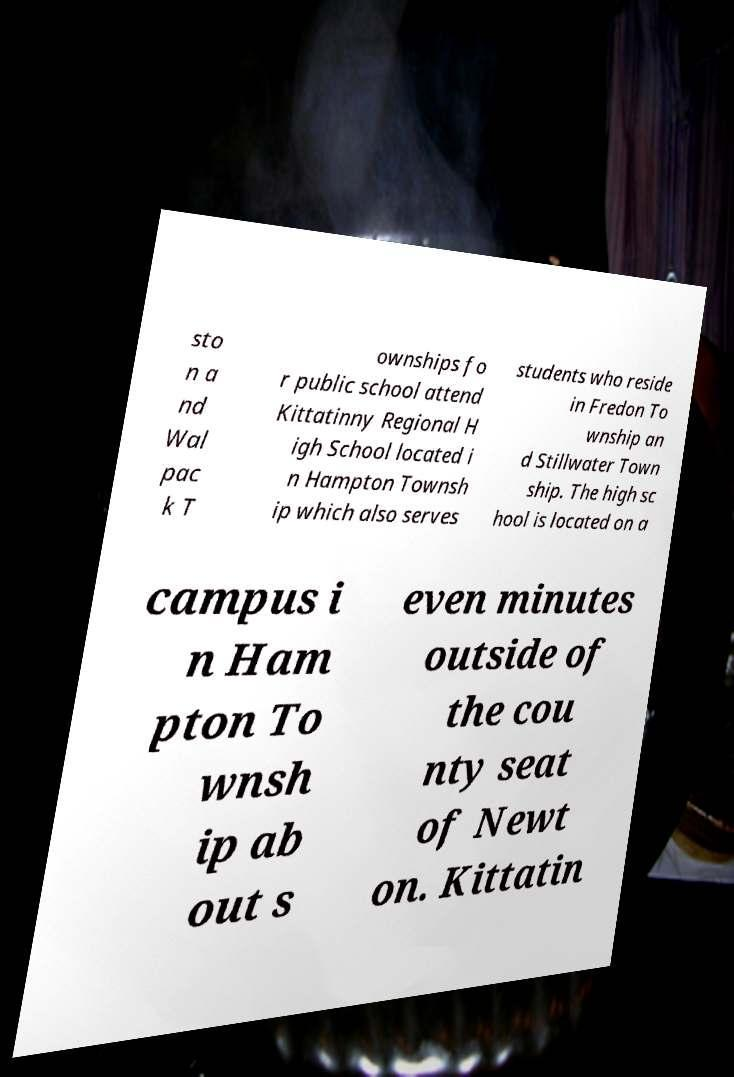Can you read and provide the text displayed in the image?This photo seems to have some interesting text. Can you extract and type it out for me? sto n a nd Wal pac k T ownships fo r public school attend Kittatinny Regional H igh School located i n Hampton Townsh ip which also serves students who reside in Fredon To wnship an d Stillwater Town ship. The high sc hool is located on a campus i n Ham pton To wnsh ip ab out s even minutes outside of the cou nty seat of Newt on. Kittatin 